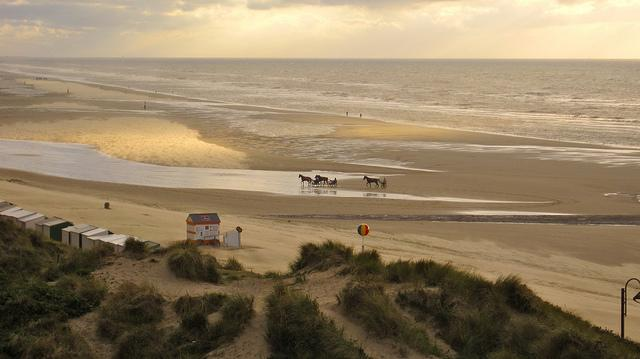What are the horses doing?

Choices:
A) feeding
B) resting
C) pulling surfers
D) pulling sleds pulling sleds 